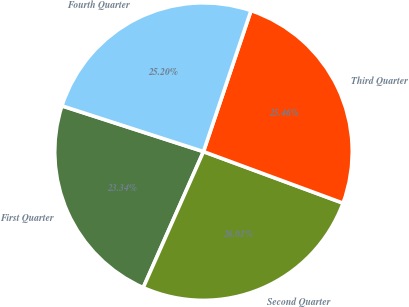Convert chart to OTSL. <chart><loc_0><loc_0><loc_500><loc_500><pie_chart><fcel>First Quarter<fcel>Second Quarter<fcel>Third Quarter<fcel>Fourth Quarter<nl><fcel>23.34%<fcel>26.01%<fcel>25.46%<fcel>25.2%<nl></chart> 